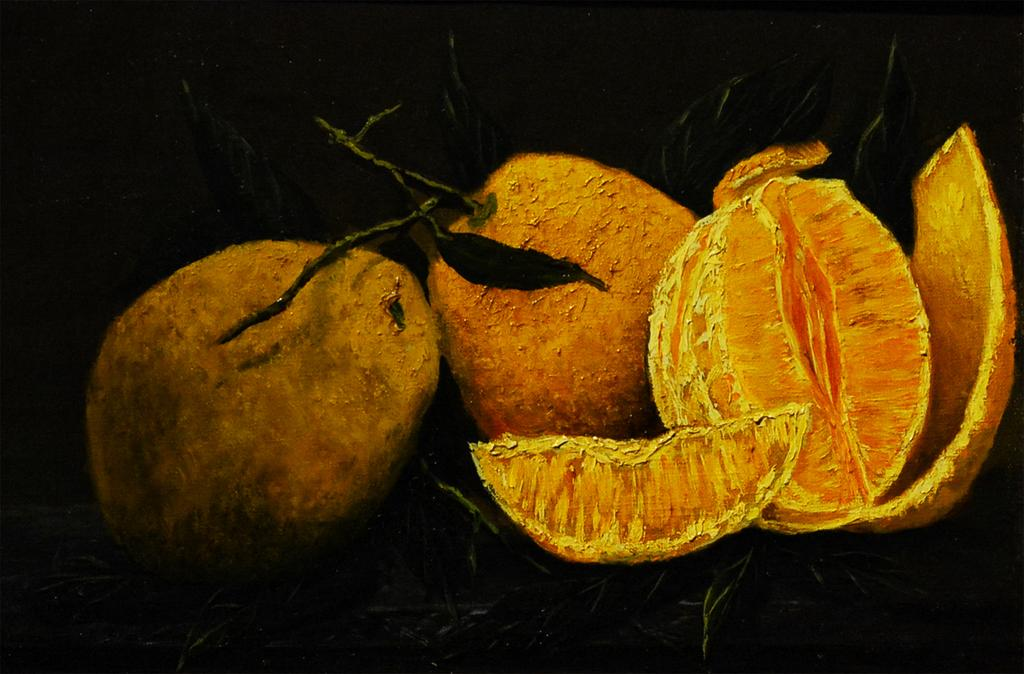What type of fruit is depicted in the image? The image contains a depiction of oranges. What other elements are present in the image besides the oranges? The image contains a depiction of leaves. How many cars can be seen driving through the oranges in the image? There are no cars present in the image; it features a depiction of oranges and leaves. What type of rod is used to pick the oranges in the image? There is no rod present in the image, as it is a depiction rather than a photograph or illustration of real oranges. 